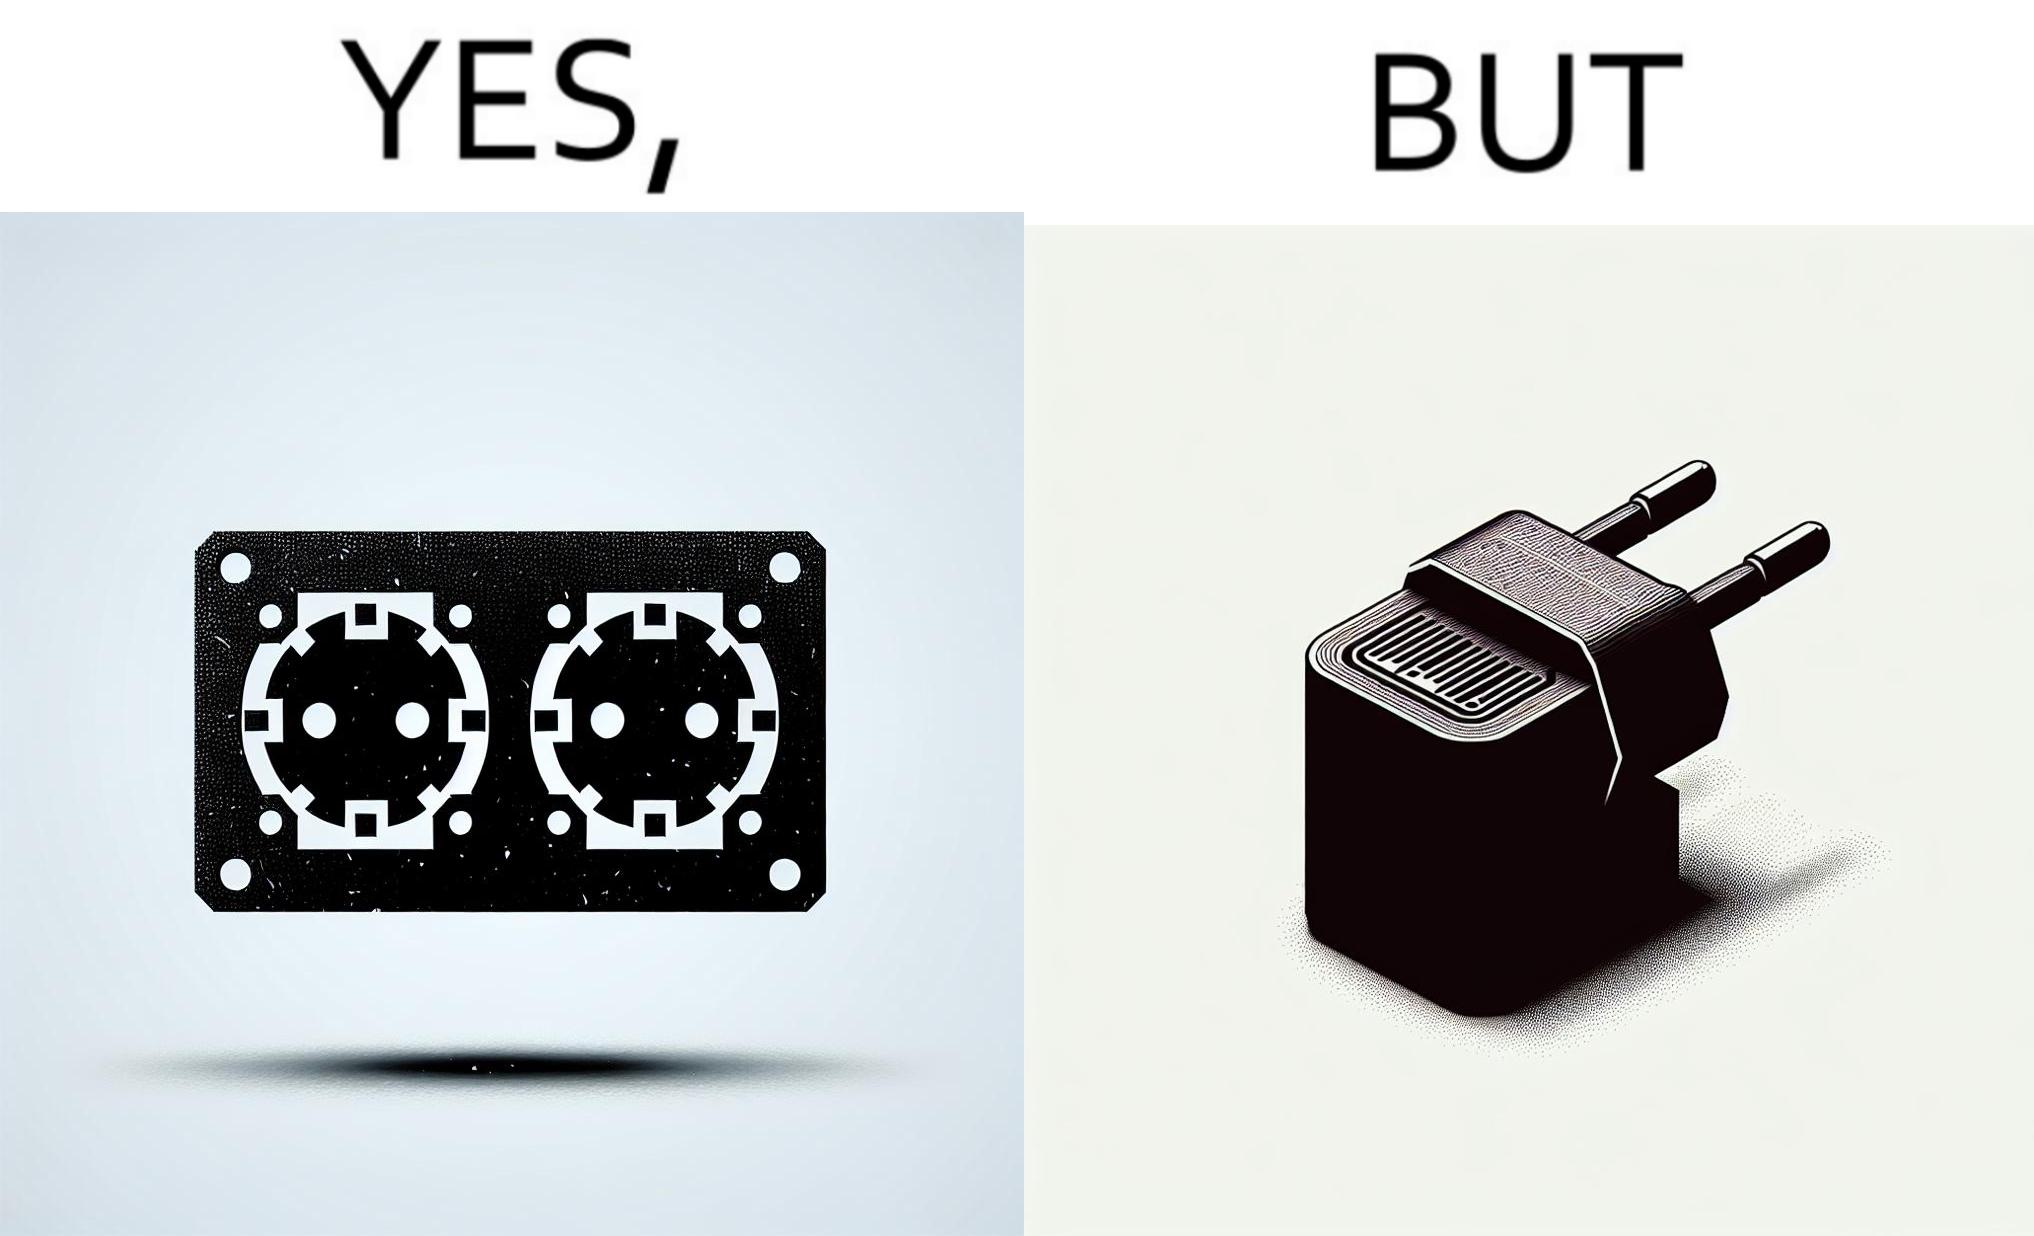Is this a satirical image? Yes, this image is satirical. 